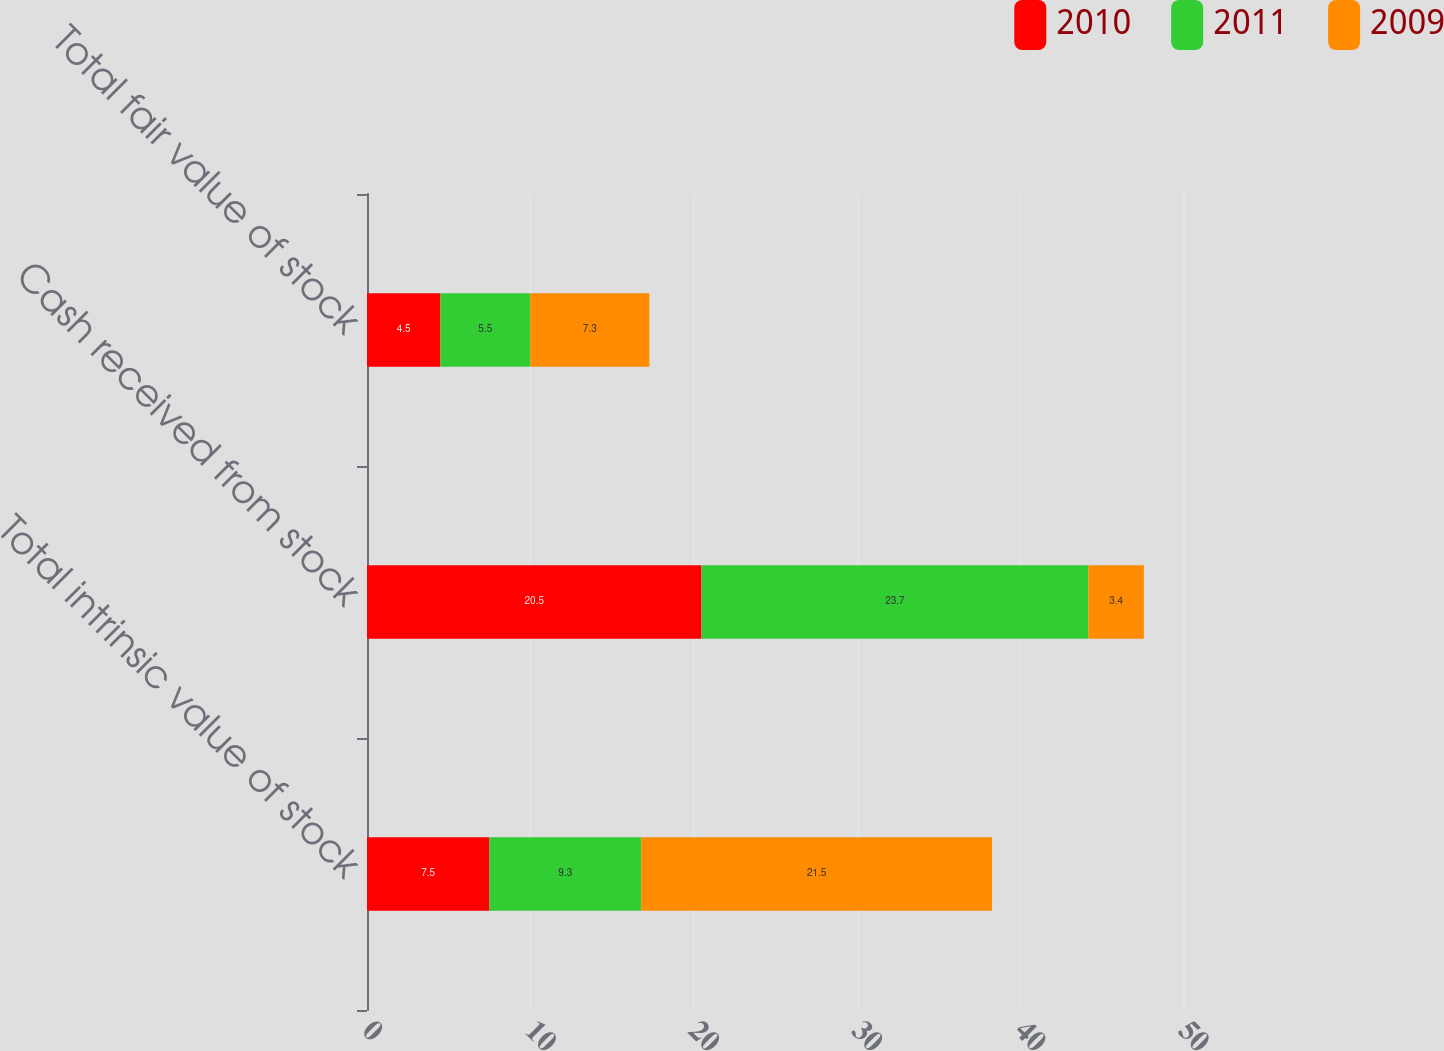Convert chart to OTSL. <chart><loc_0><loc_0><loc_500><loc_500><stacked_bar_chart><ecel><fcel>Total intrinsic value of stock<fcel>Cash received from stock<fcel>Total fair value of stock<nl><fcel>2010<fcel>7.5<fcel>20.5<fcel>4.5<nl><fcel>2011<fcel>9.3<fcel>23.7<fcel>5.5<nl><fcel>2009<fcel>21.5<fcel>3.4<fcel>7.3<nl></chart> 